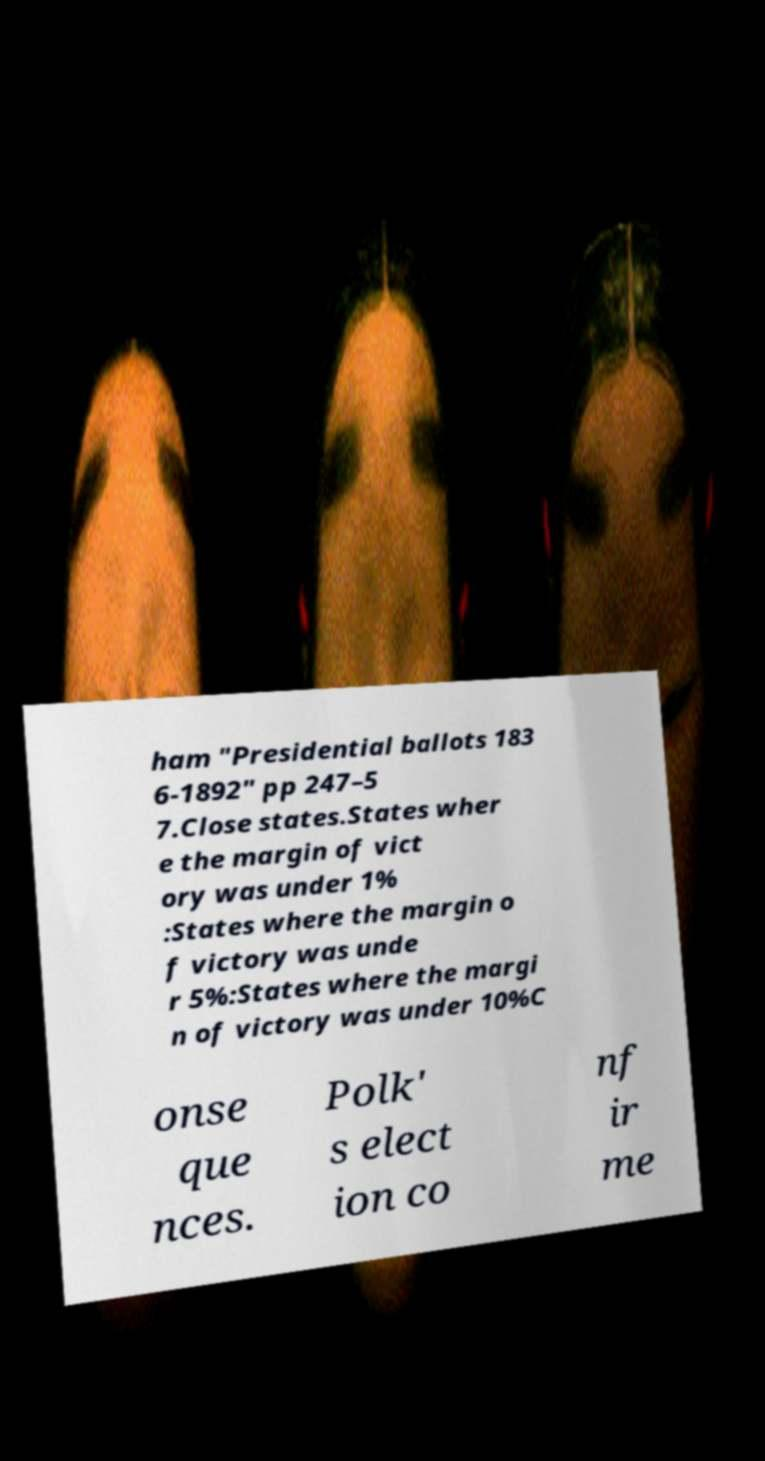I need the written content from this picture converted into text. Can you do that? ham "Presidential ballots 183 6-1892" pp 247–5 7.Close states.States wher e the margin of vict ory was under 1% :States where the margin o f victory was unde r 5%:States where the margi n of victory was under 10%C onse que nces. Polk' s elect ion co nf ir me 